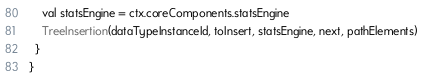<code> <loc_0><loc_0><loc_500><loc_500><_Scala_>    val statsEngine = ctx.coreComponents.statsEngine
    TreeInsertion(dataTypeInstanceId, toInsert, statsEngine, next, pathElements)
  }
}
</code> 